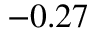Convert formula to latex. <formula><loc_0><loc_0><loc_500><loc_500>- 0 . 2 7</formula> 